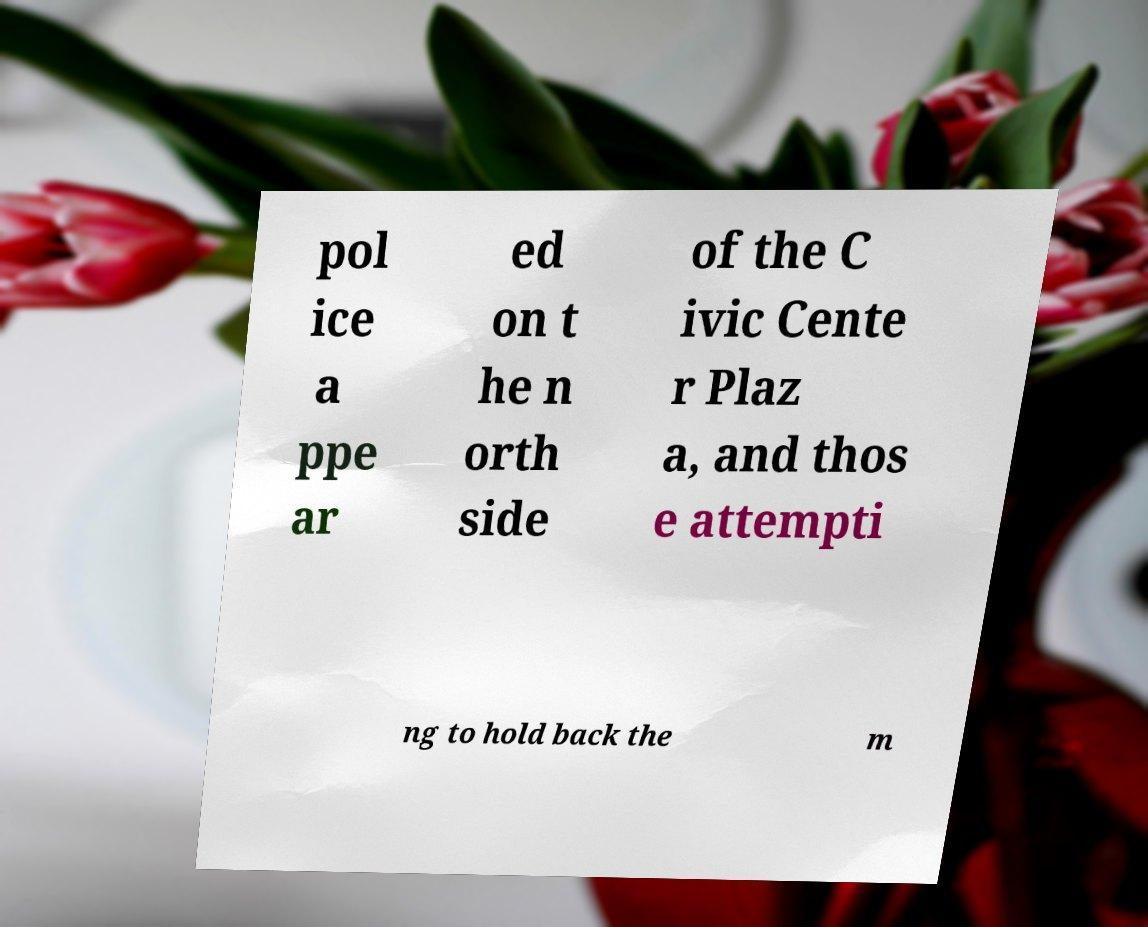What messages or text are displayed in this image? I need them in a readable, typed format. pol ice a ppe ar ed on t he n orth side of the C ivic Cente r Plaz a, and thos e attempti ng to hold back the m 